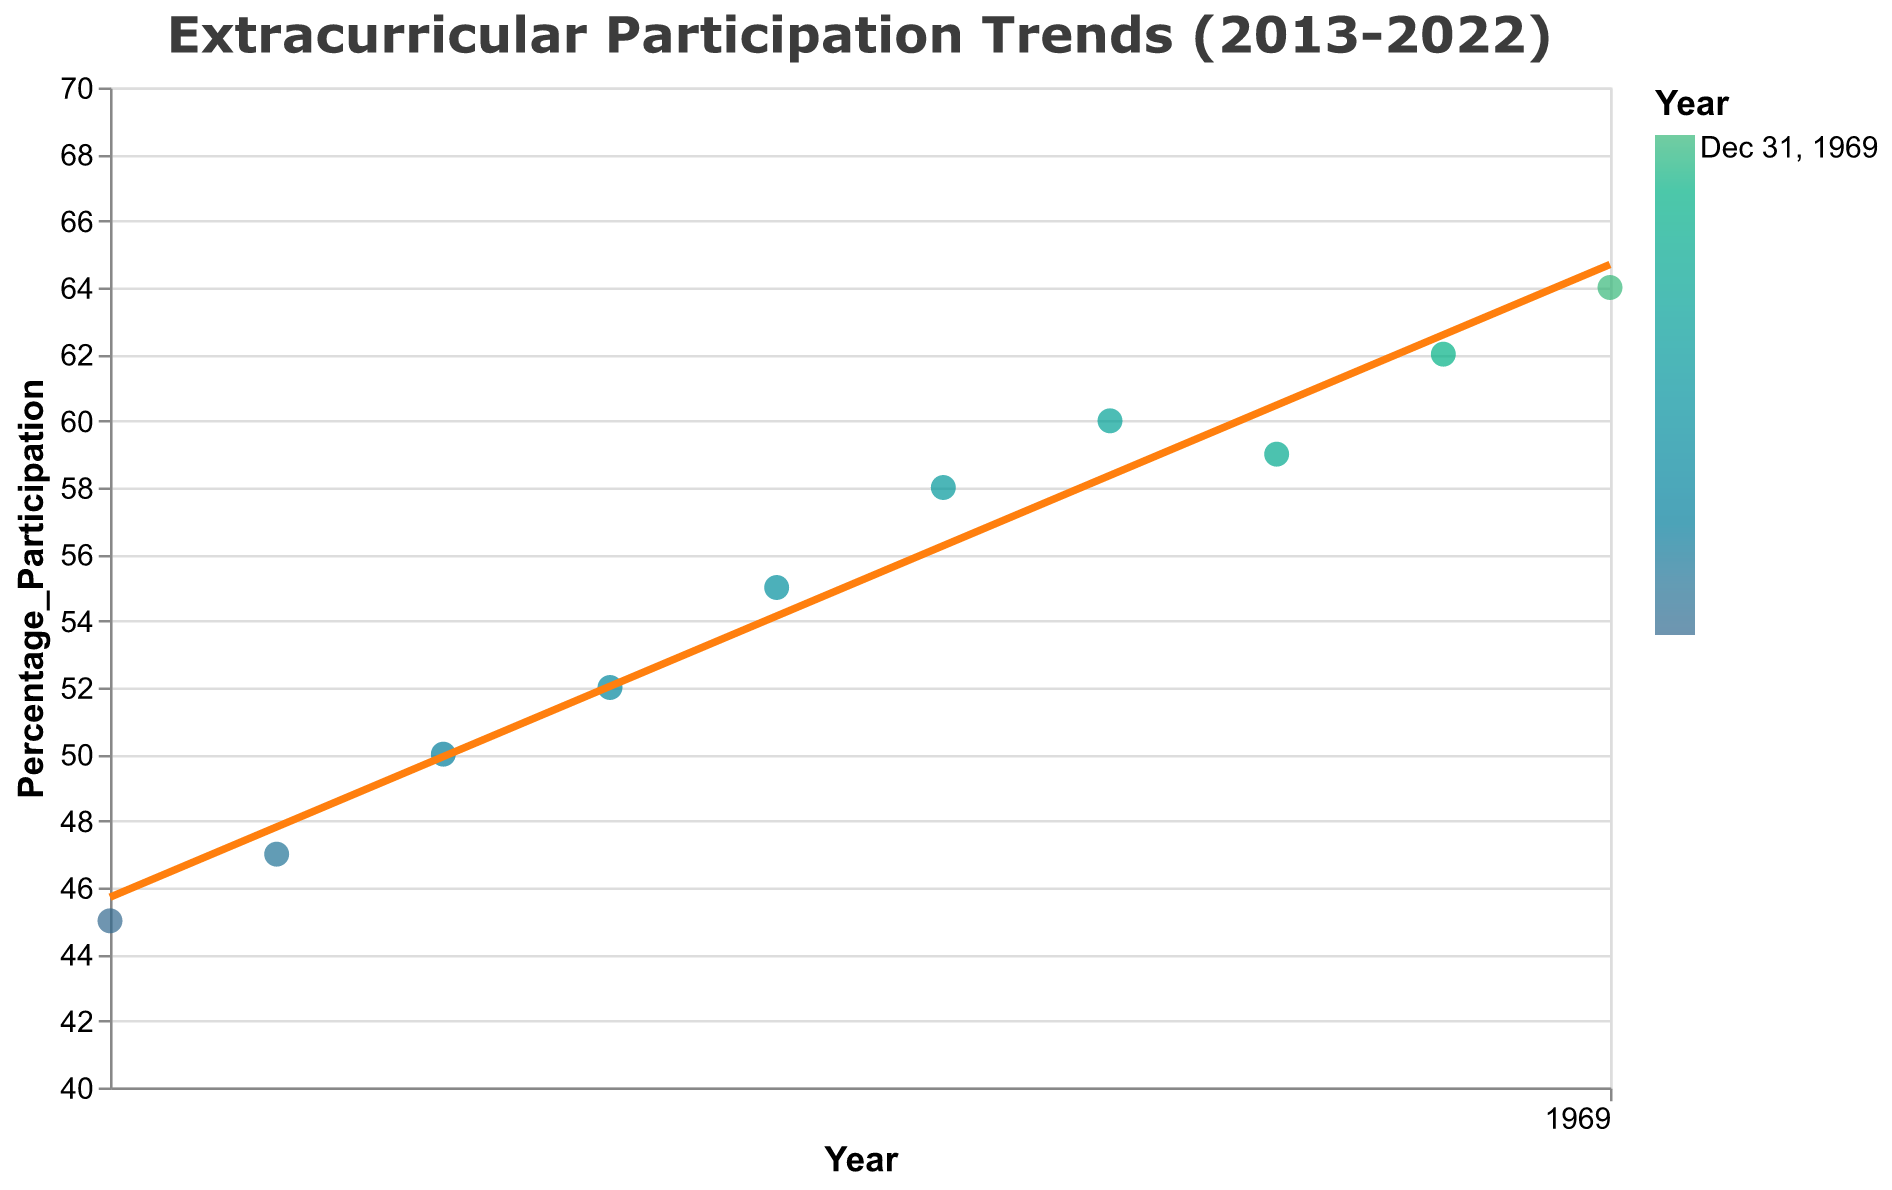What is the title of the scatter plot? The title of a plot is typically displayed at the top and describes the content of the visualization.
Answer: Extracurricular Participation Trends (2013-2022) How many data points are shown in the scatter plot? Each data point represents a year from 2013 to 2022. To determine the number of data points, count how many years are represented.
Answer: 10 Between what years did the extracurricular participation percentage increase the most? To find the largest increase in participation percentage, calculate the difference between consecutive years and identify the maximum increase.
Answer: 2021 to 2022 How does the participation percentage in 2020 compare to 2019? Look at the participation percentage for both 2019 and 2020, and compare the values to identify any increase or decrease.
Answer: Decreased What is the overall trend shown by the trend line? The trend line is a regression line that shows the overall pattern in the data. Observe the slope of the trend line to determine if it indicates an increasing or decreasing trend.
Answer: Increasing Which year had the highest percentage of participation? Identify the data point with the highest y-value (Percentage_Participation), and note the corresponding year (x-value).
Answer: 2022 What was the percentage participation in 2017? Locate the data point for the year 2017 on the x-axis and note the corresponding y-value, which represents the participation percentage.
Answer: 55% Calculate the average participation percentage from 2013 to 2022. Sum all the participation percentages from 2013 to 2022 and divide by the number of years (10) to find the average.
Answer: 55.2% Explain the dip in participation percentage in 2020 and the following increase in 2021. The plot shows a decrease in participation percentage in 2020 followed by an increase in 2021. One possible reason is external factors like the impact of the COVID-19 pandemic on extracurricular activities, followed by a recovery in 2021.
Answer: COVID-19 impact in 2020, recovery in 2021 